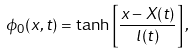Convert formula to latex. <formula><loc_0><loc_0><loc_500><loc_500>\phi _ { 0 } ( x , t ) = \tanh \left [ \frac { x - X ( t ) } { l ( t ) } \right ] ,</formula> 